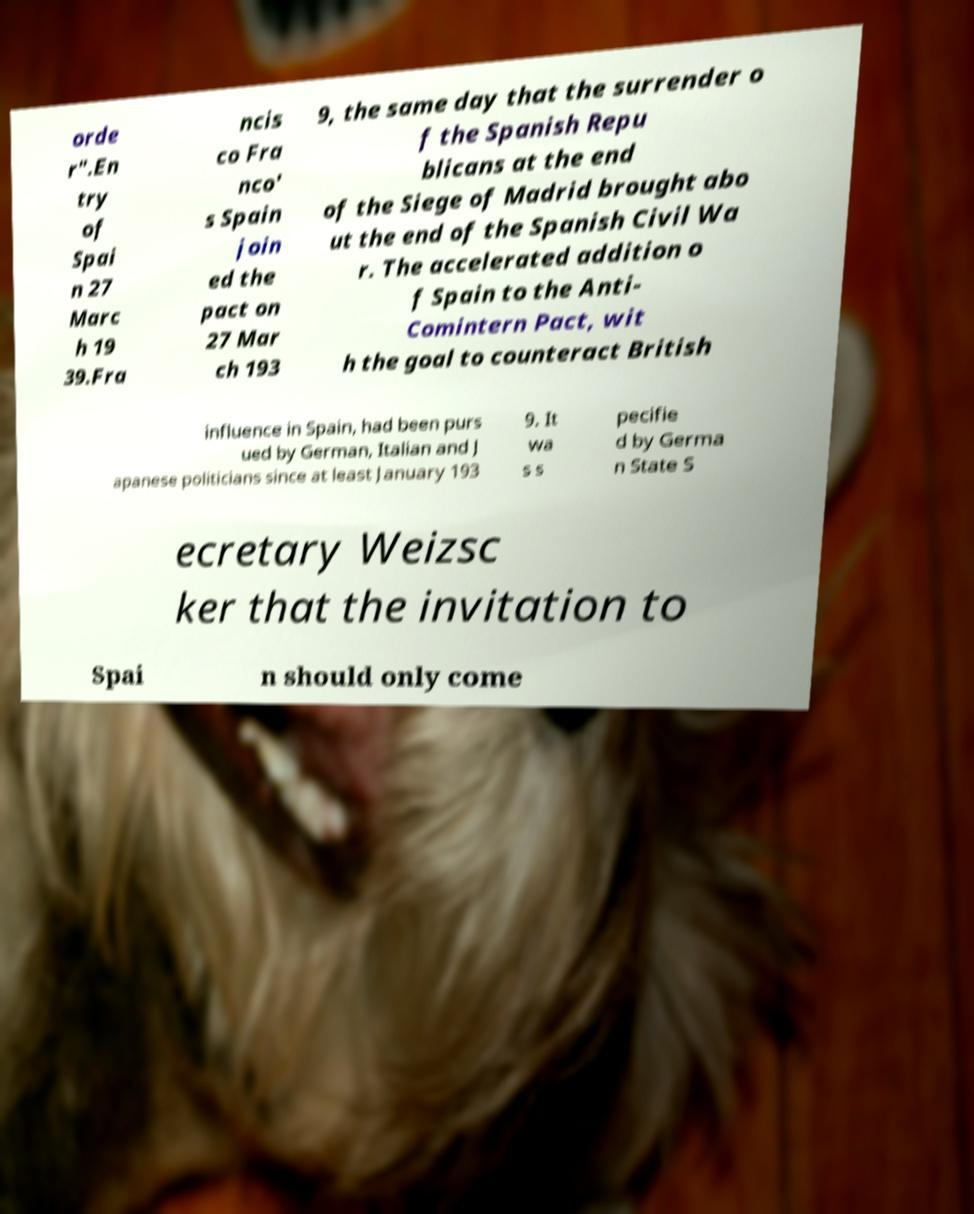Could you extract and type out the text from this image? orde r".En try of Spai n 27 Marc h 19 39.Fra ncis co Fra nco' s Spain join ed the pact on 27 Mar ch 193 9, the same day that the surrender o f the Spanish Repu blicans at the end of the Siege of Madrid brought abo ut the end of the Spanish Civil Wa r. The accelerated addition o f Spain to the Anti- Comintern Pact, wit h the goal to counteract British influence in Spain, had been purs ued by German, Italian and J apanese politicians since at least January 193 9. It wa s s pecifie d by Germa n State S ecretary Weizsc ker that the invitation to Spai n should only come 